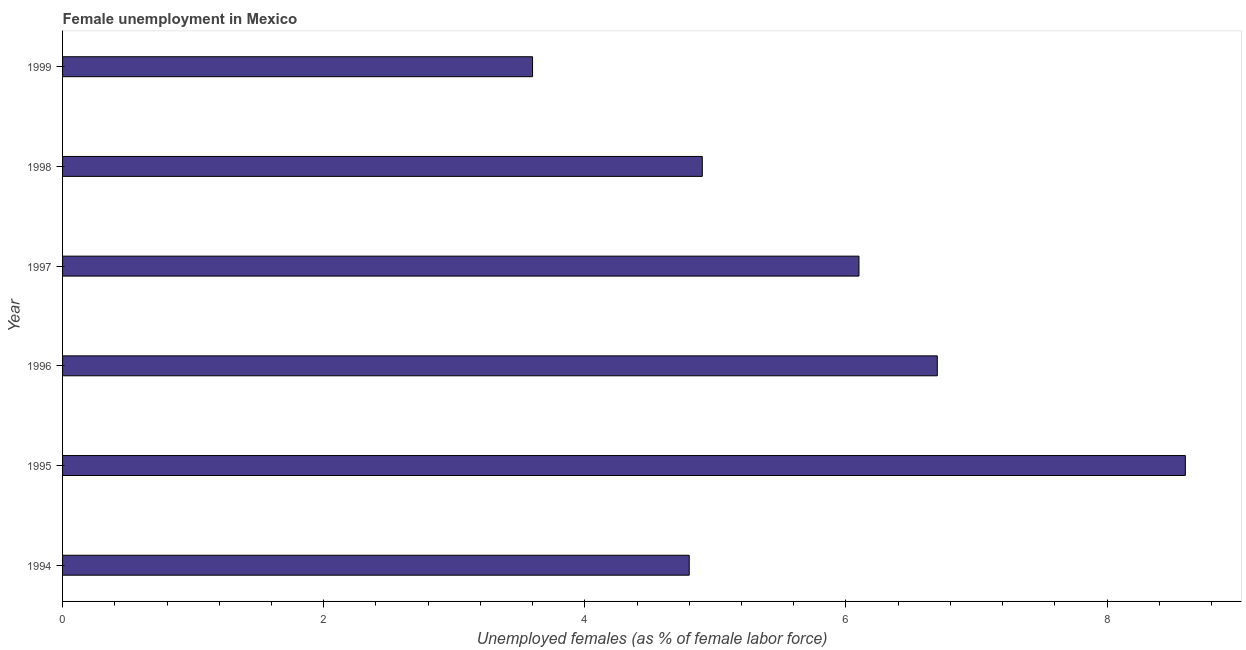Does the graph contain grids?
Make the answer very short. No. What is the title of the graph?
Provide a short and direct response. Female unemployment in Mexico. What is the label or title of the X-axis?
Your answer should be compact. Unemployed females (as % of female labor force). What is the unemployed females population in 1996?
Provide a short and direct response. 6.7. Across all years, what is the maximum unemployed females population?
Offer a terse response. 8.6. Across all years, what is the minimum unemployed females population?
Ensure brevity in your answer.  3.6. In which year was the unemployed females population minimum?
Provide a short and direct response. 1999. What is the sum of the unemployed females population?
Provide a short and direct response. 34.7. What is the average unemployed females population per year?
Offer a terse response. 5.78. Do a majority of the years between 1999 and 1997 (inclusive) have unemployed females population greater than 5.6 %?
Your response must be concise. Yes. What is the ratio of the unemployed females population in 1995 to that in 1996?
Provide a short and direct response. 1.28. Is the unemployed females population in 1996 less than that in 1997?
Make the answer very short. No. Is the difference between the unemployed females population in 1996 and 1998 greater than the difference between any two years?
Your response must be concise. No. Is the sum of the unemployed females population in 1995 and 1998 greater than the maximum unemployed females population across all years?
Provide a succinct answer. Yes. What is the difference between the highest and the lowest unemployed females population?
Your answer should be compact. 5. In how many years, is the unemployed females population greater than the average unemployed females population taken over all years?
Offer a terse response. 3. What is the Unemployed females (as % of female labor force) in 1994?
Keep it short and to the point. 4.8. What is the Unemployed females (as % of female labor force) in 1995?
Keep it short and to the point. 8.6. What is the Unemployed females (as % of female labor force) of 1996?
Your answer should be very brief. 6.7. What is the Unemployed females (as % of female labor force) of 1997?
Give a very brief answer. 6.1. What is the Unemployed females (as % of female labor force) in 1998?
Your answer should be compact. 4.9. What is the Unemployed females (as % of female labor force) in 1999?
Provide a succinct answer. 3.6. What is the difference between the Unemployed females (as % of female labor force) in 1994 and 1995?
Give a very brief answer. -3.8. What is the difference between the Unemployed females (as % of female labor force) in 1994 and 1997?
Give a very brief answer. -1.3. What is the difference between the Unemployed females (as % of female labor force) in 1995 and 1997?
Provide a succinct answer. 2.5. What is the difference between the Unemployed females (as % of female labor force) in 1995 and 1999?
Your answer should be very brief. 5. What is the difference between the Unemployed females (as % of female labor force) in 1996 and 1997?
Ensure brevity in your answer.  0.6. What is the difference between the Unemployed females (as % of female labor force) in 1996 and 1999?
Your answer should be very brief. 3.1. What is the difference between the Unemployed females (as % of female labor force) in 1997 and 1998?
Offer a very short reply. 1.2. What is the difference between the Unemployed females (as % of female labor force) in 1997 and 1999?
Your response must be concise. 2.5. What is the difference between the Unemployed females (as % of female labor force) in 1998 and 1999?
Make the answer very short. 1.3. What is the ratio of the Unemployed females (as % of female labor force) in 1994 to that in 1995?
Keep it short and to the point. 0.56. What is the ratio of the Unemployed females (as % of female labor force) in 1994 to that in 1996?
Your answer should be very brief. 0.72. What is the ratio of the Unemployed females (as % of female labor force) in 1994 to that in 1997?
Provide a succinct answer. 0.79. What is the ratio of the Unemployed females (as % of female labor force) in 1994 to that in 1998?
Offer a very short reply. 0.98. What is the ratio of the Unemployed females (as % of female labor force) in 1994 to that in 1999?
Offer a terse response. 1.33. What is the ratio of the Unemployed females (as % of female labor force) in 1995 to that in 1996?
Provide a short and direct response. 1.28. What is the ratio of the Unemployed females (as % of female labor force) in 1995 to that in 1997?
Provide a succinct answer. 1.41. What is the ratio of the Unemployed females (as % of female labor force) in 1995 to that in 1998?
Make the answer very short. 1.75. What is the ratio of the Unemployed females (as % of female labor force) in 1995 to that in 1999?
Ensure brevity in your answer.  2.39. What is the ratio of the Unemployed females (as % of female labor force) in 1996 to that in 1997?
Make the answer very short. 1.1. What is the ratio of the Unemployed females (as % of female labor force) in 1996 to that in 1998?
Make the answer very short. 1.37. What is the ratio of the Unemployed females (as % of female labor force) in 1996 to that in 1999?
Your answer should be very brief. 1.86. What is the ratio of the Unemployed females (as % of female labor force) in 1997 to that in 1998?
Your answer should be very brief. 1.25. What is the ratio of the Unemployed females (as % of female labor force) in 1997 to that in 1999?
Ensure brevity in your answer.  1.69. What is the ratio of the Unemployed females (as % of female labor force) in 1998 to that in 1999?
Your answer should be very brief. 1.36. 